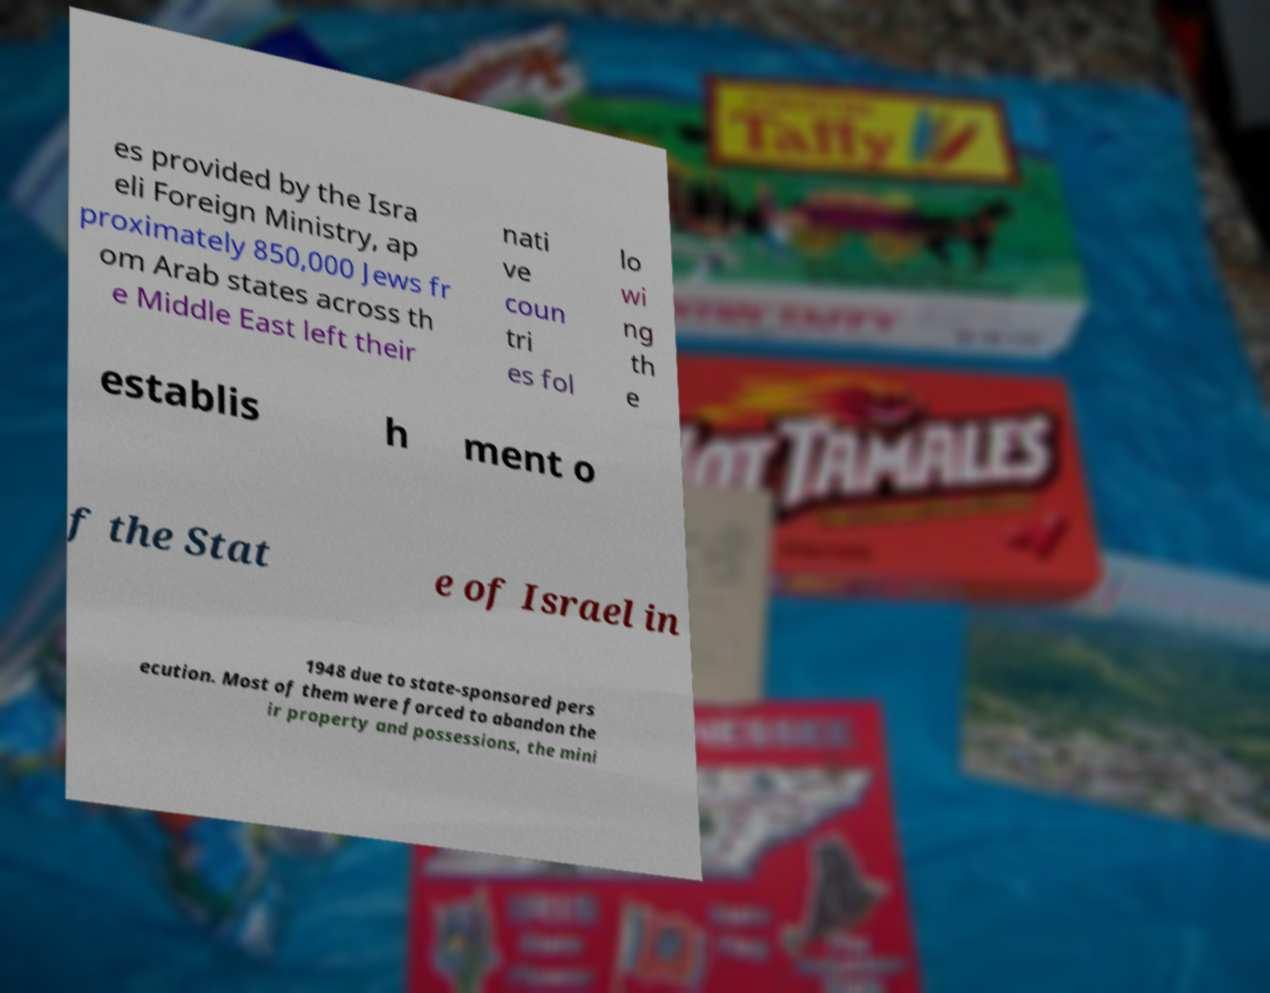Can you accurately transcribe the text from the provided image for me? es provided by the Isra eli Foreign Ministry, ap proximately 850,000 Jews fr om Arab states across th e Middle East left their nati ve coun tri es fol lo wi ng th e establis h ment o f the Stat e of Israel in 1948 due to state-sponsored pers ecution. Most of them were forced to abandon the ir property and possessions, the mini 